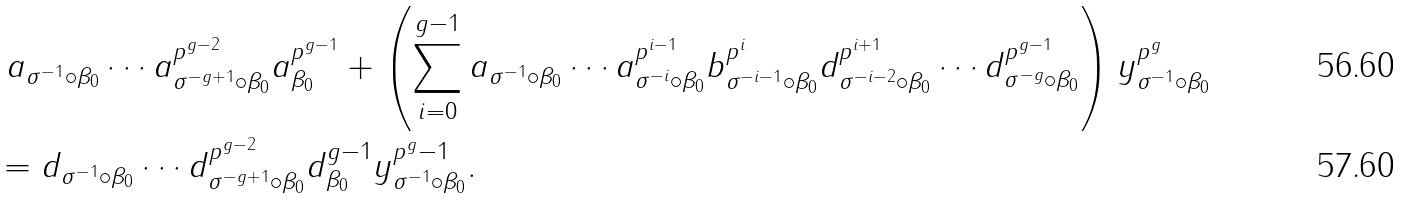Convert formula to latex. <formula><loc_0><loc_0><loc_500><loc_500>& \ a _ { \sigma ^ { - 1 } \circ \beta _ { 0 } } \cdots a _ { \sigma ^ { - g + 1 } \circ \beta _ { 0 } } ^ { p ^ { g - 2 } } a _ { \beta _ { 0 } } ^ { p ^ { g - 1 } } + \left ( \sum _ { i = 0 } ^ { g - 1 } a _ { \sigma ^ { - 1 } \circ \beta _ { 0 } } \cdots a _ { \sigma ^ { - i } \circ \beta _ { 0 } } ^ { p ^ { i - 1 } } b _ { \sigma ^ { - i - 1 } \circ \beta _ { 0 } } ^ { p ^ { i } } d _ { \sigma ^ { - i - 2 } \circ \beta _ { 0 } } ^ { p ^ { i + 1 } } \cdots d _ { \sigma ^ { - g } \circ \beta _ { 0 } } ^ { p ^ { g - 1 } } \right ) y ^ { p ^ { g } } _ { \sigma ^ { - 1 } \circ \beta _ { 0 } } \\ & = d _ { \sigma ^ { - 1 } \circ \beta _ { 0 } } \cdots d _ { \sigma ^ { - g + 1 } \circ \beta _ { 0 } } ^ { p ^ { g - 2 } } d _ { \beta _ { 0 } } ^ { g - 1 } y _ { \sigma ^ { - 1 } \circ \beta _ { 0 } } ^ { p ^ { g } - 1 } .</formula> 